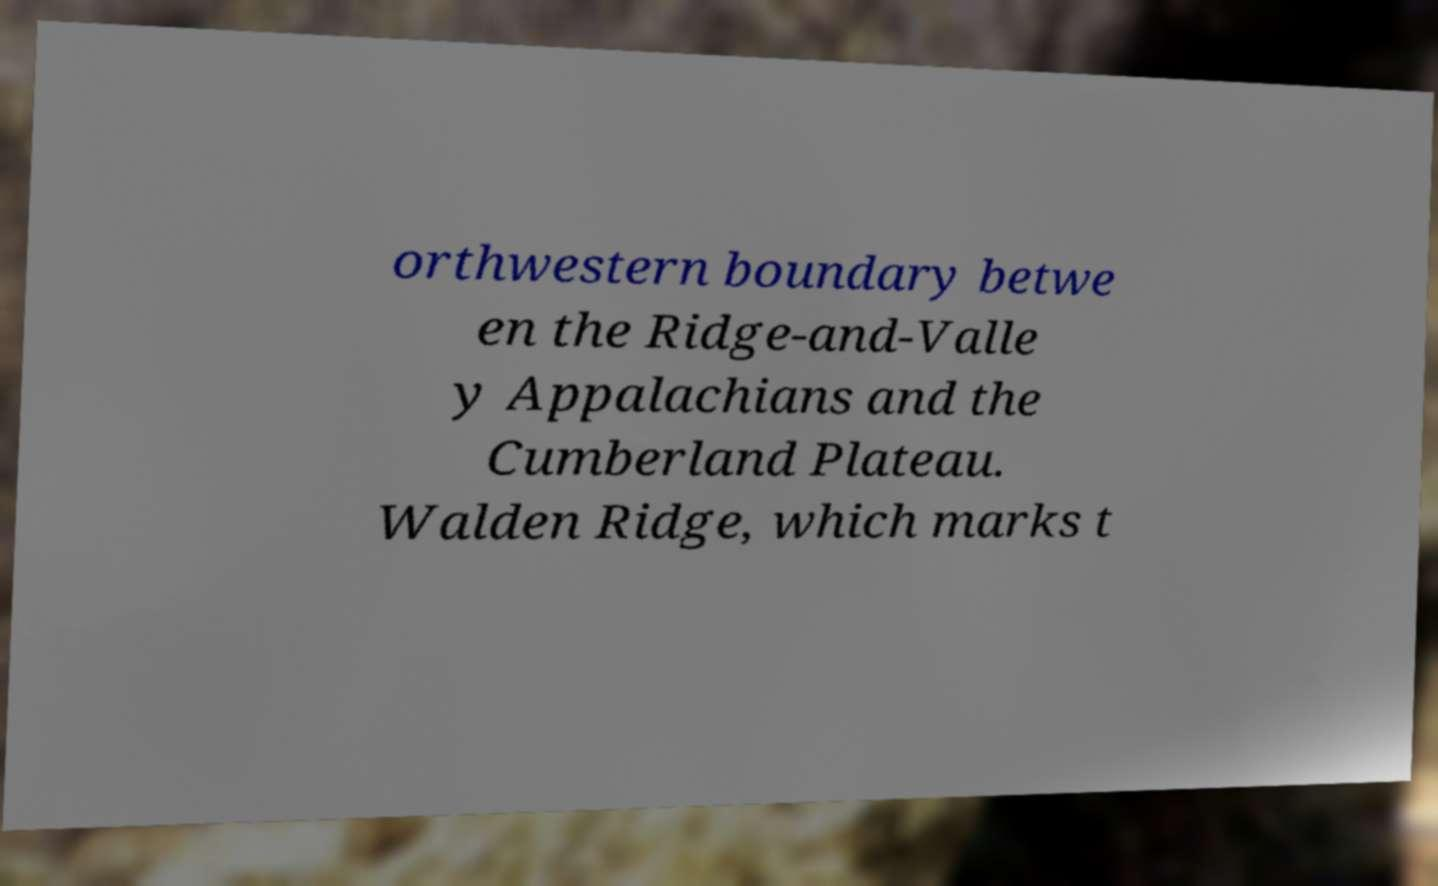I need the written content from this picture converted into text. Can you do that? orthwestern boundary betwe en the Ridge-and-Valle y Appalachians and the Cumberland Plateau. Walden Ridge, which marks t 